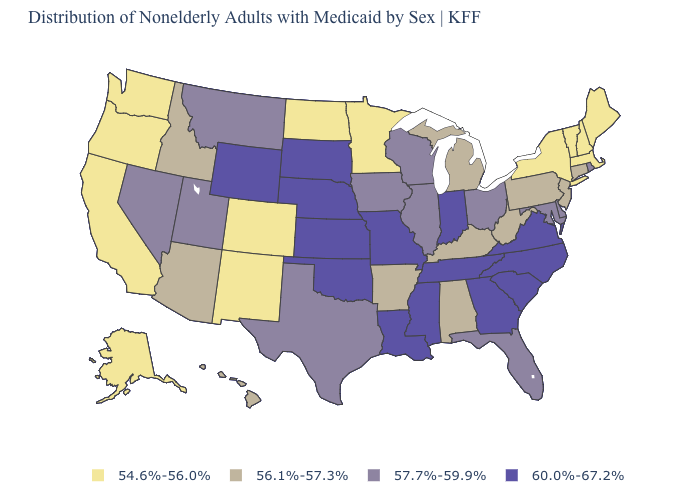Among the states that border Georgia , does Alabama have the lowest value?
Short answer required. Yes. Name the states that have a value in the range 56.1%-57.3%?
Short answer required. Alabama, Arizona, Arkansas, Connecticut, Hawaii, Idaho, Kentucky, Michigan, New Jersey, Pennsylvania, West Virginia. What is the value of Delaware?
Concise answer only. 57.7%-59.9%. What is the value of Delaware?
Write a very short answer. 57.7%-59.9%. Does Delaware have a lower value than Connecticut?
Concise answer only. No. What is the value of Alaska?
Quick response, please. 54.6%-56.0%. What is the value of Missouri?
Short answer required. 60.0%-67.2%. How many symbols are there in the legend?
Concise answer only. 4. Among the states that border New York , which have the highest value?
Keep it brief. Connecticut, New Jersey, Pennsylvania. Name the states that have a value in the range 54.6%-56.0%?
Give a very brief answer. Alaska, California, Colorado, Maine, Massachusetts, Minnesota, New Hampshire, New Mexico, New York, North Dakota, Oregon, Vermont, Washington. Name the states that have a value in the range 57.7%-59.9%?
Short answer required. Delaware, Florida, Illinois, Iowa, Maryland, Montana, Nevada, Ohio, Rhode Island, Texas, Utah, Wisconsin. Name the states that have a value in the range 60.0%-67.2%?
Write a very short answer. Georgia, Indiana, Kansas, Louisiana, Mississippi, Missouri, Nebraska, North Carolina, Oklahoma, South Carolina, South Dakota, Tennessee, Virginia, Wyoming. Does Washington have a lower value than Utah?
Write a very short answer. Yes. What is the value of Alaska?
Give a very brief answer. 54.6%-56.0%. Name the states that have a value in the range 56.1%-57.3%?
Write a very short answer. Alabama, Arizona, Arkansas, Connecticut, Hawaii, Idaho, Kentucky, Michigan, New Jersey, Pennsylvania, West Virginia. 